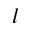Convert formula to latex. <formula><loc_0><loc_0><loc_500><loc_500>l</formula> 